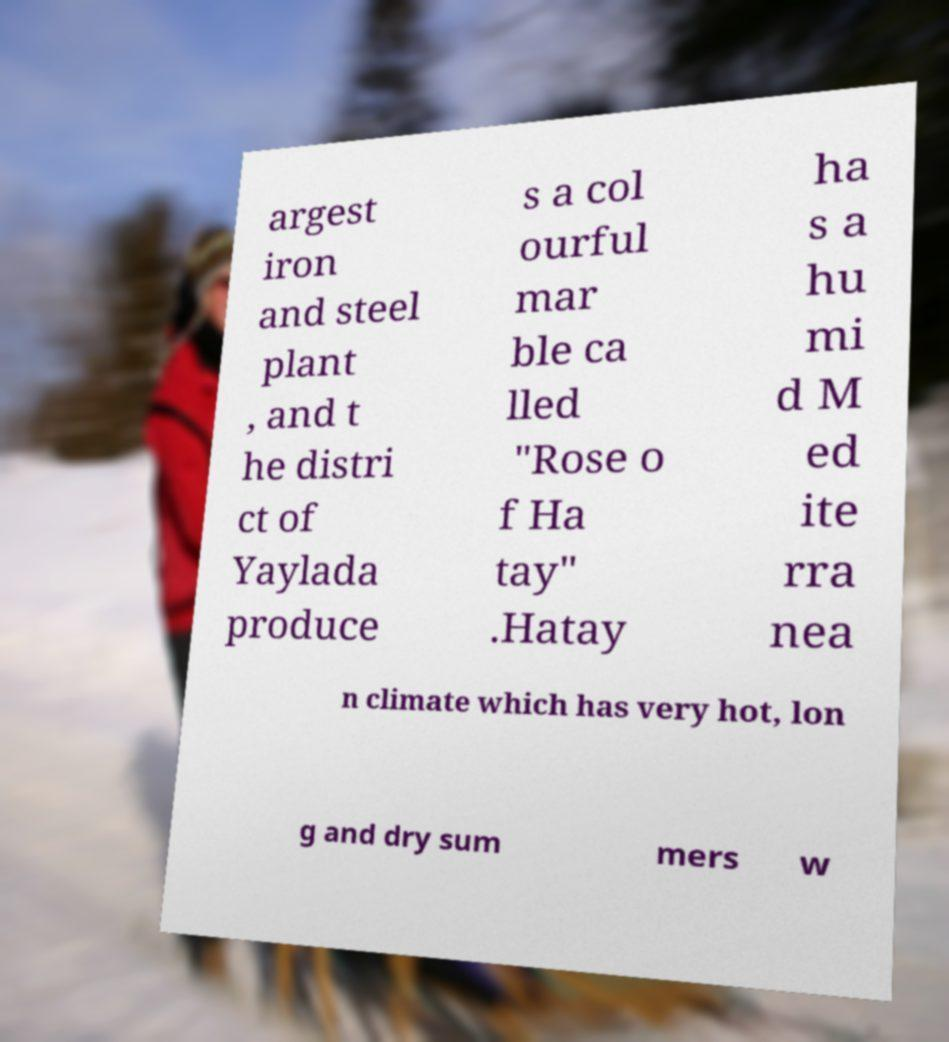What messages or text are displayed in this image? I need them in a readable, typed format. argest iron and steel plant , and t he distri ct of Yaylada produce s a col ourful mar ble ca lled "Rose o f Ha tay" .Hatay ha s a hu mi d M ed ite rra nea n climate which has very hot, lon g and dry sum mers w 